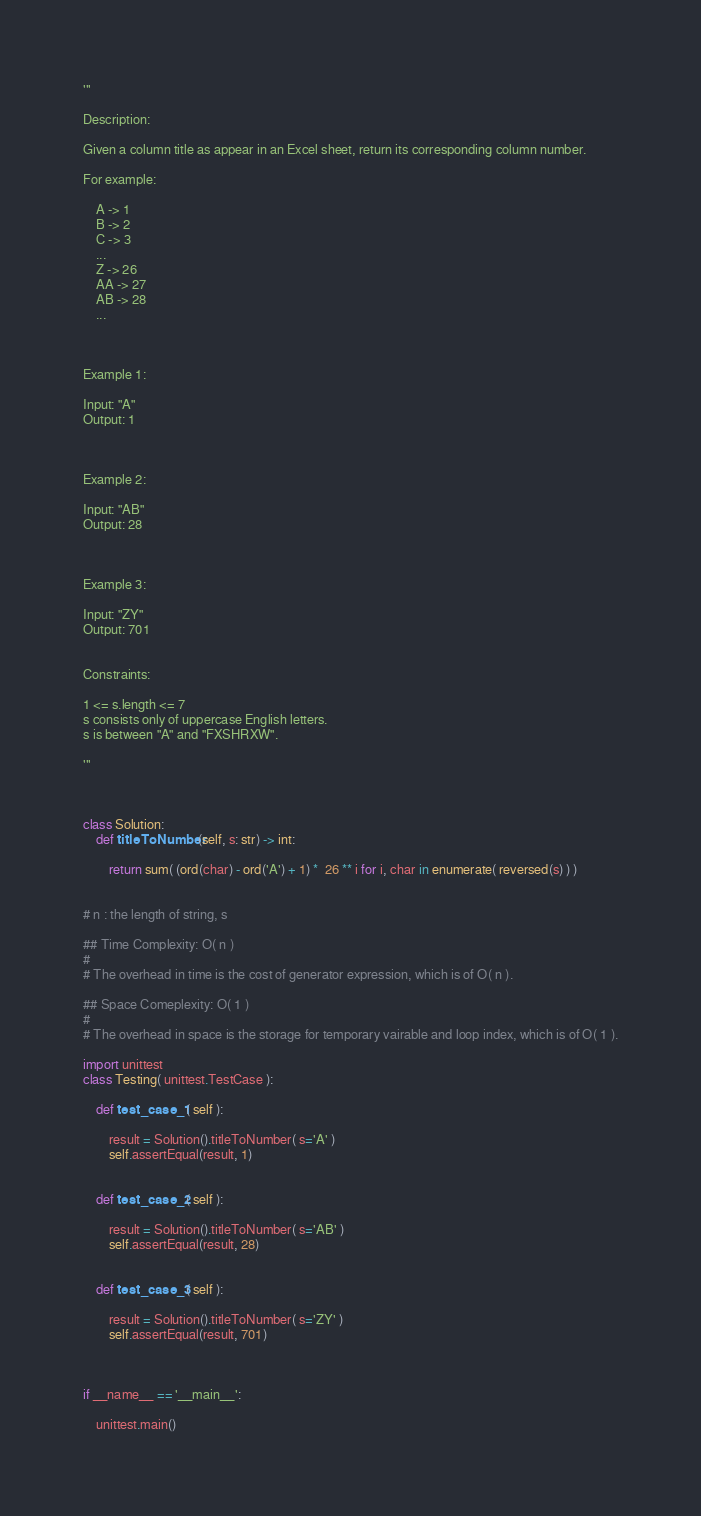Convert code to text. <code><loc_0><loc_0><loc_500><loc_500><_Python_>'''

Description:

Given a column title as appear in an Excel sheet, return its corresponding column number.

For example:

    A -> 1
    B -> 2
    C -> 3
    ...
    Z -> 26
    AA -> 27
    AB -> 28 
    ...



Example 1:

Input: "A"
Output: 1



Example 2:

Input: "AB"
Output: 28



Example 3:

Input: "ZY"
Output: 701
 

Constraints:

1 <= s.length <= 7
s consists only of uppercase English letters.
s is between "A" and "FXSHRXW".

'''



class Solution:
    def titleToNumber(self, s: str) -> int:

        return sum( (ord(char) - ord('A') + 1) *  26 ** i for i, char in enumerate( reversed(s) ) )


# n : the length of string, s

## Time Complexity: O( n )
#
# The overhead in time is the cost of generator expression, which is of O( n ).

## Space Comeplexity: O( 1 )
#
# The overhead in space is the storage for temporary vairable and loop index, which is of O( 1 ).

import unittest
class Testing( unittest.TestCase ):

    def test_case_1( self ):

        result = Solution().titleToNumber( s='A' )
        self.assertEqual(result, 1)

    
    def test_case_2( self ):

        result = Solution().titleToNumber( s='AB' )
        self.assertEqual(result, 28)


    def test_case_3( self ):

        result = Solution().titleToNumber( s='ZY' )
        self.assertEqual(result, 701)



if __name__ == '__main__':

    unittest.main()</code> 